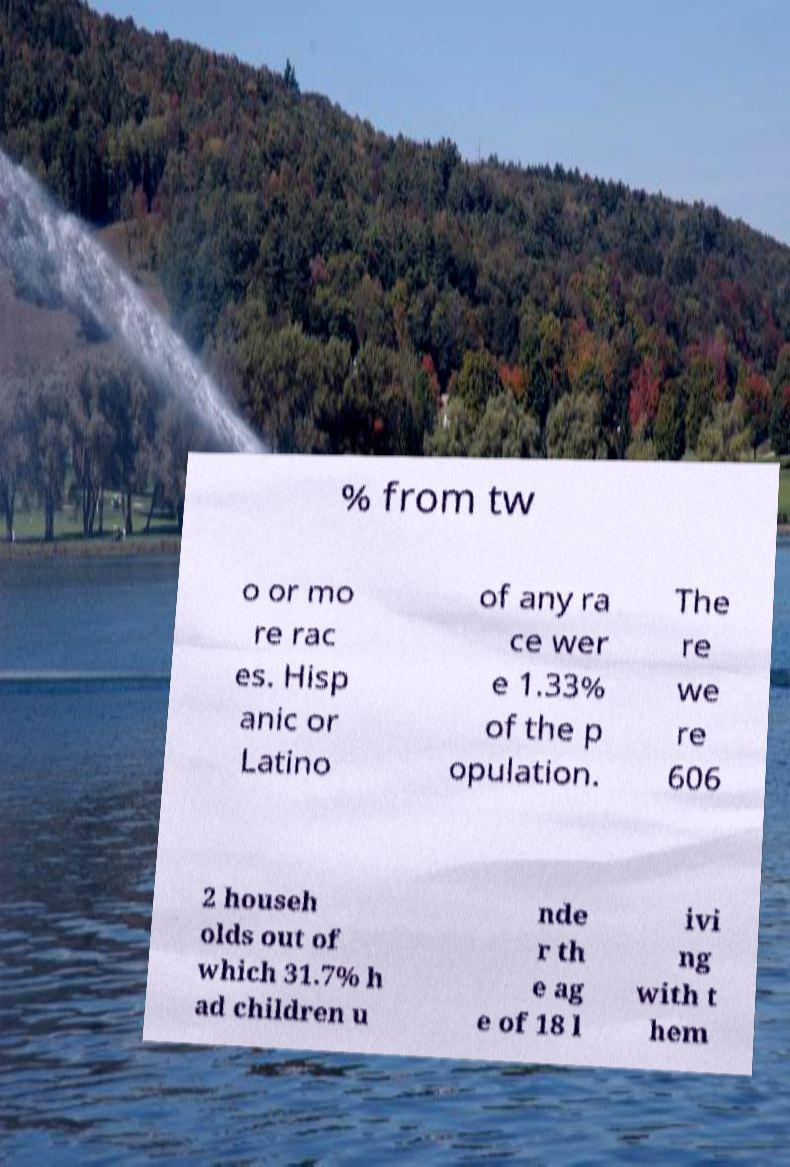There's text embedded in this image that I need extracted. Can you transcribe it verbatim? % from tw o or mo re rac es. Hisp anic or Latino of any ra ce wer e 1.33% of the p opulation. The re we re 606 2 househ olds out of which 31.7% h ad children u nde r th e ag e of 18 l ivi ng with t hem 